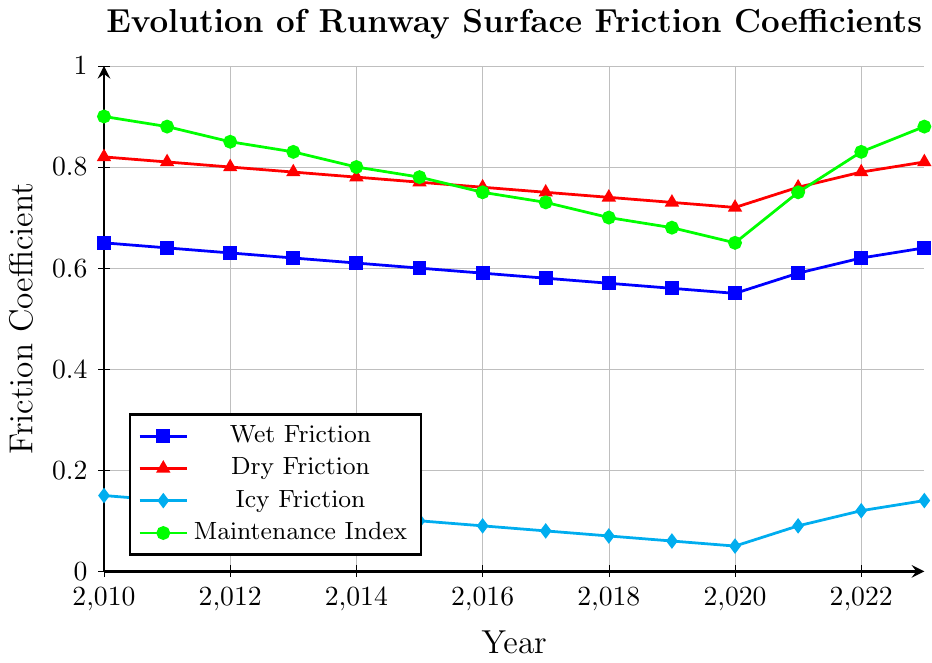What trend can be observed for the wet friction coefficient from 2010 to 2020? To determine the trend, we observe the line representing the Wet Friction coefficient. It decreases from 0.65 in 2010 to 0.55 in 2020.
Answer: Decreasing How did the Dry Friction coefficient change between 2010 and 2023? We examine the Dry Friction line and note that it started at 0.82 in 2010, decreased steadily to 0.72 in 2020, then increased to 0.81 in 2023.
Answer: Increased slightly What is the range of the Icy Friction coefficient between 2010 and 2023? The Icy Friction coefficient varies from a maximum of 0.15 in 2010 to a minimum of 0.05 in 2020.
Answer: 0.10 Which friction coefficient saw the most improvement from 2020 to 2023? Comparing the lines for Wet, Dry, and Icy Friction from 2020 to 2023: Wet increased from 0.55 to 0.64 (+0.09), Dry from 0.72 to 0.81 (+0.09), and Icy from 0.05 to 0.14 (+0.09). They all saw equal improvement.
Answer: All improved equally What is the relationship between the Maintenance Index and Wet Friction coefficient from 2020 to 2023? Both the Maintenance Index and Wet Friction show an increasing trend, indicating a possible correlation.
Answer: Positive correlation By how much did the Maintenance Index change from 2010 to 2020? The Maintenance Index decreased from 0.9 in 2010 to 0.65 in 2020, a difference of 0.9 - 0.65 = 0.25.
Answer: 0.25 What was the general trend of the Maintenance Index from 2010 to 2020, and how did it change afterward up to 2023? From 2010 to 2020, the Maintenance Index generally decreased from 0.9 to 0.65. After 2020, it increased back to 0.88 by 2023.
Answer: Decreased then increased Which year had the highest dry friction coefficient and what was its value? The Dry Friction line peaks at 0.82 in 2010.
Answer: 2010, 0.82 What's the percentage increase in the Wet Friction coefficient from 2020 to 2023? Wet Friction increased from 0.55 in 2020 to 0.64 in 2023. The percentage increase is ((0.64 - 0.55) / 0.55) * 100 = 16.36%.
Answer: 16.36% 